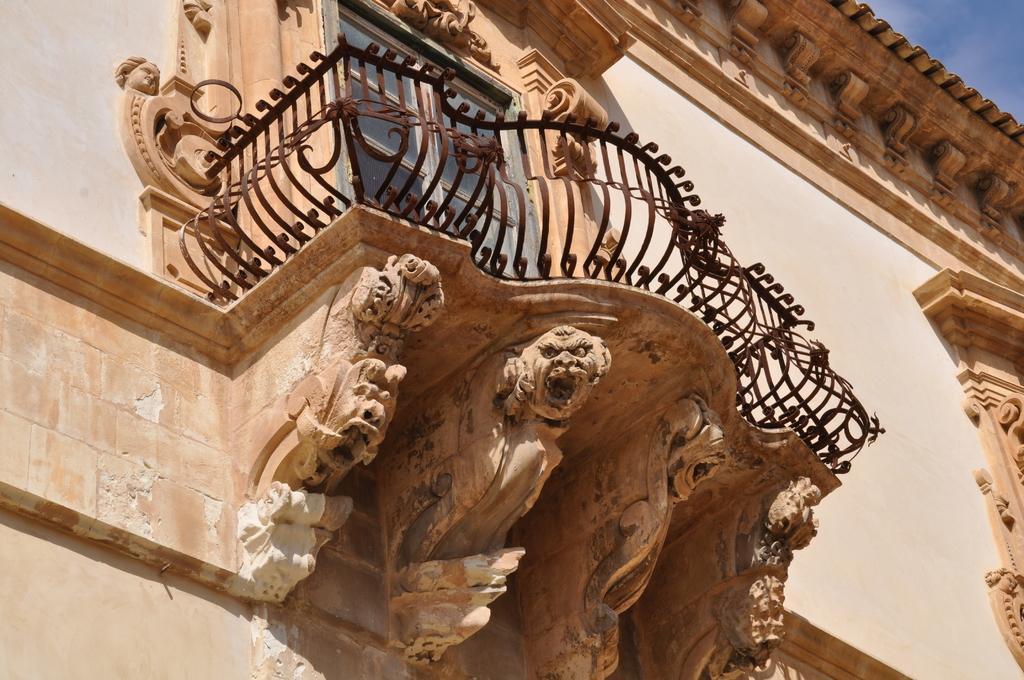Can you describe this image briefly? In this picture there is a iron fence and there is a glass door behind it and there is sculpture on the walls. 